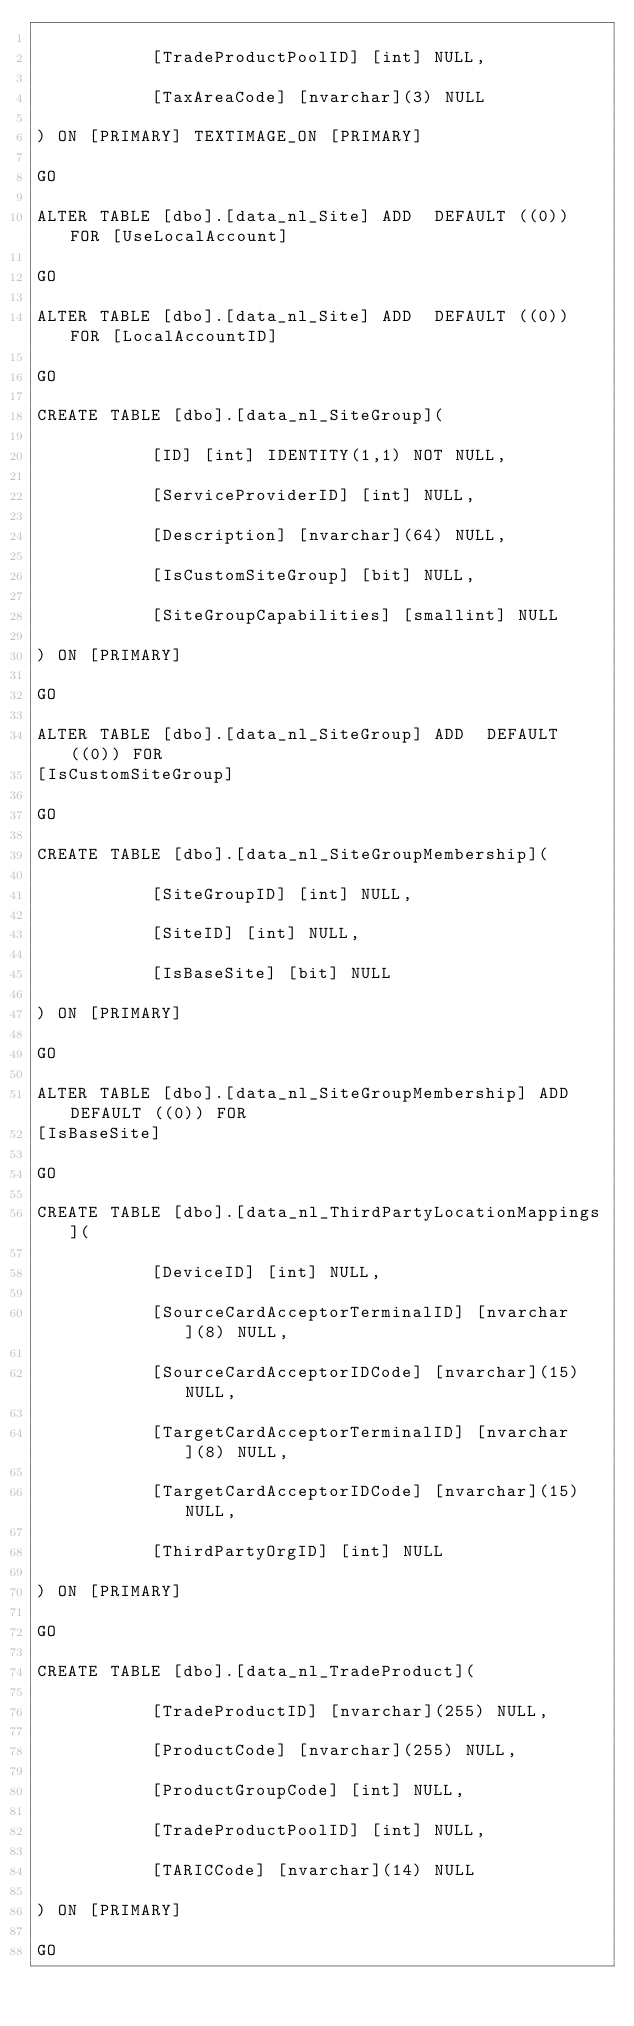<code> <loc_0><loc_0><loc_500><loc_500><_SQL_>
           [TradeProductPoolID] [int] NULL,

           [TaxAreaCode] [nvarchar](3) NULL

) ON [PRIMARY] TEXTIMAGE_ON [PRIMARY]

GO

ALTER TABLE [dbo].[data_nl_Site] ADD  DEFAULT ((0)) FOR [UseLocalAccount]

GO

ALTER TABLE [dbo].[data_nl_Site] ADD  DEFAULT ((0)) FOR [LocalAccountID]

GO

CREATE TABLE [dbo].[data_nl_SiteGroup](

           [ID] [int] IDENTITY(1,1) NOT NULL,

           [ServiceProviderID] [int] NULL,

           [Description] [nvarchar](64) NULL,

           [IsCustomSiteGroup] [bit] NULL,

           [SiteGroupCapabilities] [smallint] NULL

) ON [PRIMARY]

GO

ALTER TABLE [dbo].[data_nl_SiteGroup] ADD  DEFAULT ((0)) FOR
[IsCustomSiteGroup]

GO

CREATE TABLE [dbo].[data_nl_SiteGroupMembership](

           [SiteGroupID] [int] NULL,

           [SiteID] [int] NULL,

           [IsBaseSite] [bit] NULL

) ON [PRIMARY]

GO

ALTER TABLE [dbo].[data_nl_SiteGroupMembership] ADD  DEFAULT ((0)) FOR
[IsBaseSite]

GO

CREATE TABLE [dbo].[data_nl_ThirdPartyLocationMappings](

           [DeviceID] [int] NULL,

           [SourceCardAcceptorTerminalID] [nvarchar](8) NULL,

           [SourceCardAcceptorIDCode] [nvarchar](15) NULL,

           [TargetCardAcceptorTerminalID] [nvarchar](8) NULL,

           [TargetCardAcceptorIDCode] [nvarchar](15) NULL,

           [ThirdPartyOrgID] [int] NULL

) ON [PRIMARY]

GO

CREATE TABLE [dbo].[data_nl_TradeProduct](

           [TradeProductID] [nvarchar](255) NULL,

           [ProductCode] [nvarchar](255) NULL,

           [ProductGroupCode] [int] NULL,

           [TradeProductPoolID] [int] NULL,

           [TARICCode] [nvarchar](14) NULL

) ON [PRIMARY]

GO</code> 